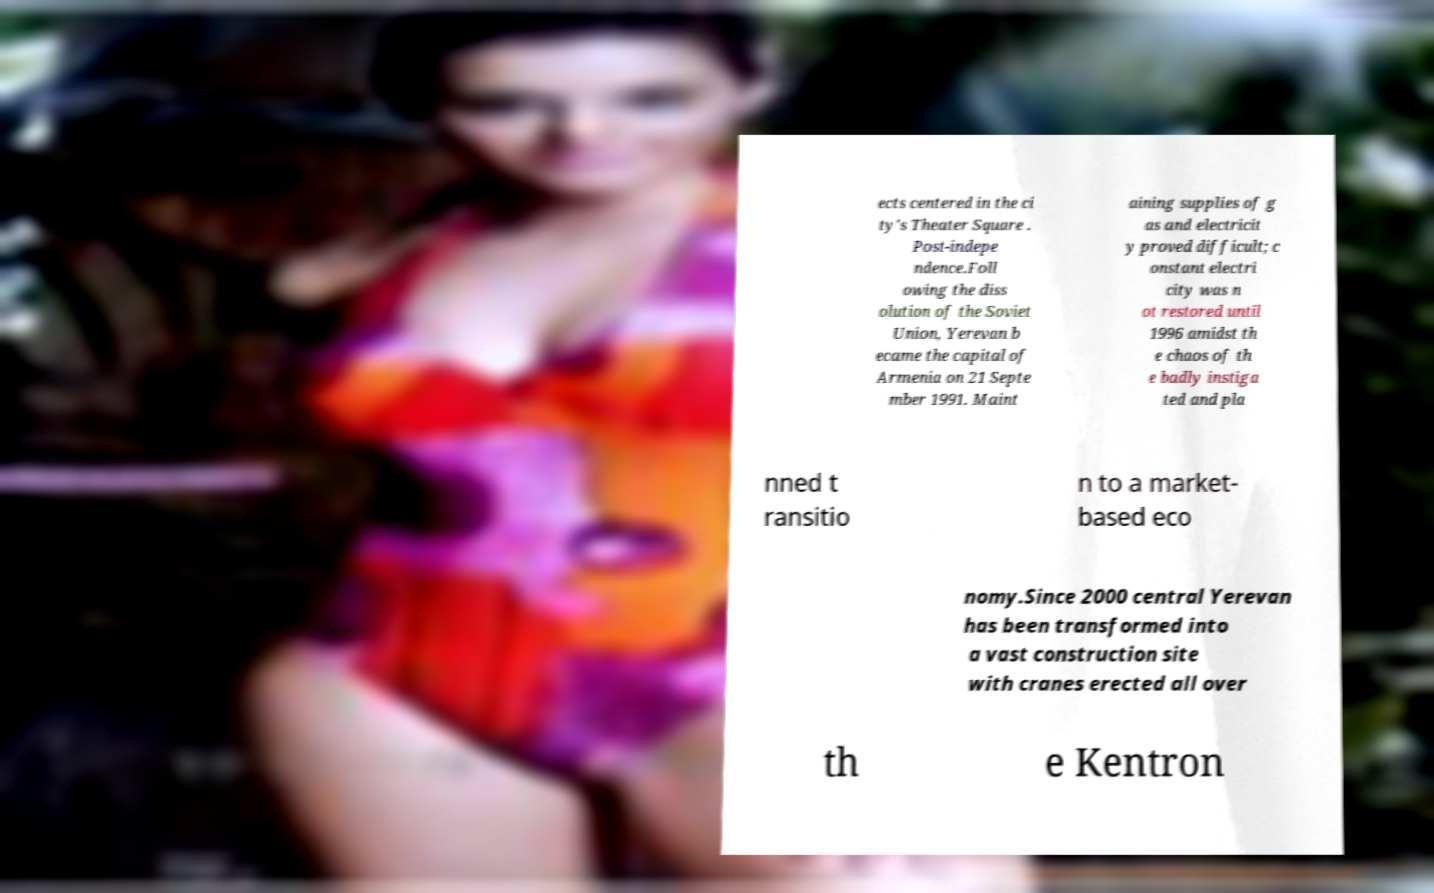What messages or text are displayed in this image? I need them in a readable, typed format. ects centered in the ci ty's Theater Square . Post-indepe ndence.Foll owing the diss olution of the Soviet Union, Yerevan b ecame the capital of Armenia on 21 Septe mber 1991. Maint aining supplies of g as and electricit y proved difficult; c onstant electri city was n ot restored until 1996 amidst th e chaos of th e badly instiga ted and pla nned t ransitio n to a market- based eco nomy.Since 2000 central Yerevan has been transformed into a vast construction site with cranes erected all over th e Kentron 